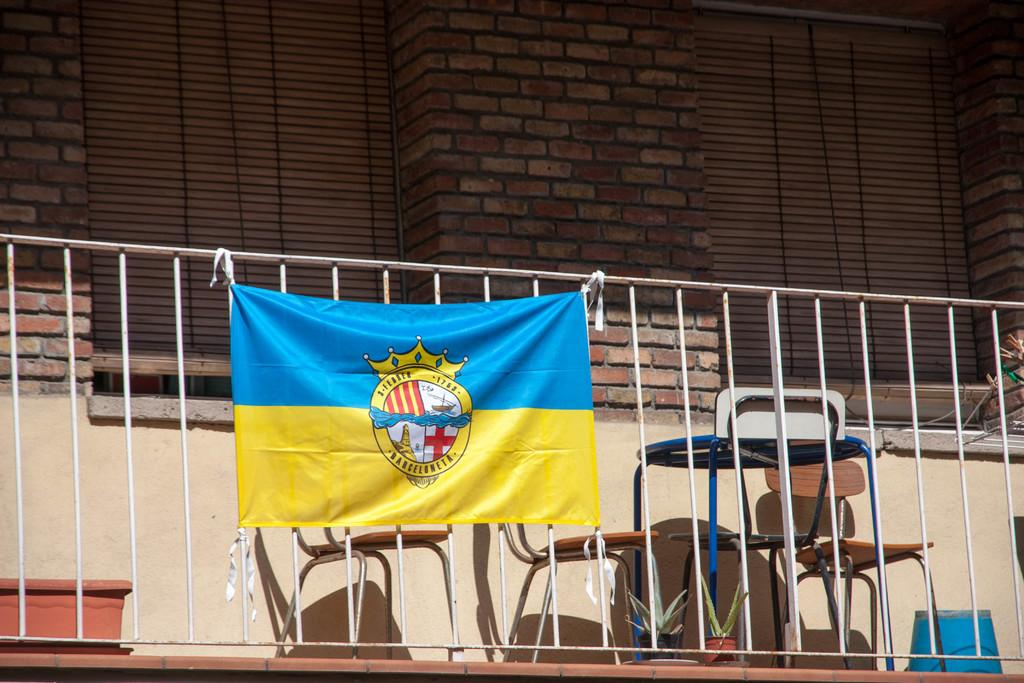What is attached to the railing in the image? There is a banner tied to the railing in the image. What type of building is visible in the image? There is a building with red bricks in the image. What feature can be seen on the windows of the building? The building has window blinds. What type of furniture is present in the image? There are chairs in the image. What type of decorative items are present in the image? There are flower pots in the image. What type of insurance is advertised on the banner in the image? There is no advertisement or mention of insurance on the banner in the image. What type of spoon is used to stir the contents of the flower pots in the image? There are no spoons present in the image, and the flower pots do not contain any contents that would require stirring. 